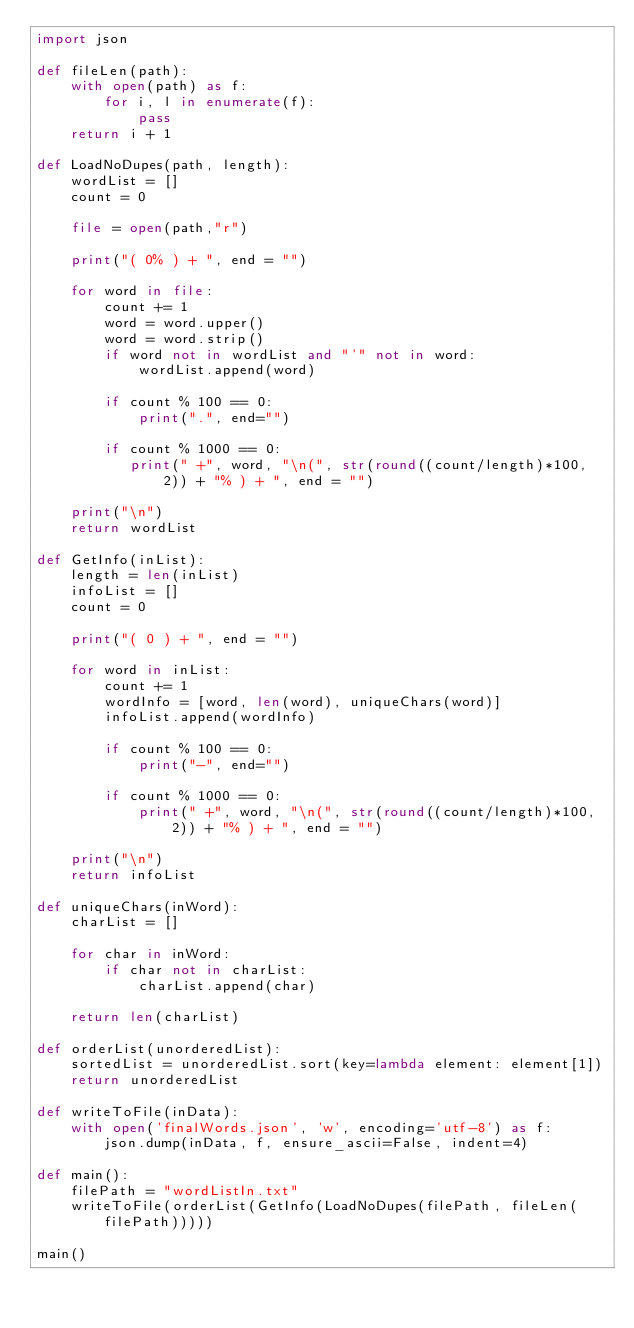Convert code to text. <code><loc_0><loc_0><loc_500><loc_500><_Python_>import json

def fileLen(path):
    with open(path) as f:
        for i, l in enumerate(f):
            pass
    return i + 1

def LoadNoDupes(path, length):
    wordList = []
    count = 0

    file = open(path,"r")

    print("( 0% ) + ", end = "")

    for word in file:
        count += 1
        word = word.upper()
        word = word.strip()
        if word not in wordList and "'" not in word:
            wordList.append(word)

        if count % 100 == 0:
            print(".", end="")

        if count % 1000 == 0:
           print(" +", word, "\n(", str(round((count/length)*100, 2)) + "% ) + ", end = "")

    print("\n")
    return wordList

def GetInfo(inList):
    length = len(inList)
    infoList = []
    count = 0

    print("( 0 ) + ", end = "")

    for word in inList:
        count += 1
        wordInfo = [word, len(word), uniqueChars(word)]
        infoList.append(wordInfo)

        if count % 100 == 0:
            print("-", end="")

        if count % 1000 == 0:
            print(" +", word, "\n(", str(round((count/length)*100, 2)) + "% ) + ", end = "")

    print("\n")
    return infoList

def uniqueChars(inWord):
    charList = []

    for char in inWord:
        if char not in charList:
            charList.append(char)

    return len(charList)

def orderList(unorderedList):
    sortedList = unorderedList.sort(key=lambda element: element[1])
    return unorderedList

def writeToFile(inData):
    with open('finalWords.json', 'w', encoding='utf-8') as f:
        json.dump(inData, f, ensure_ascii=False, indent=4)

def main():
    filePath = "wordListIn.txt"
    writeToFile(orderList(GetInfo(LoadNoDupes(filePath, fileLen(filePath)))))

main()
</code> 